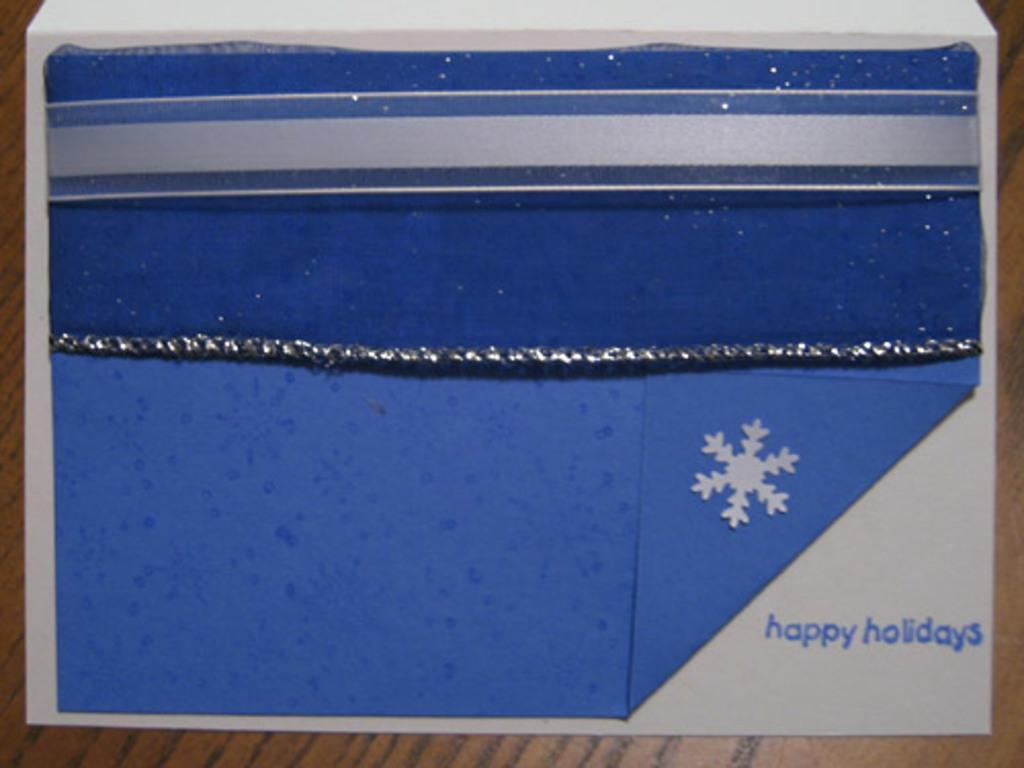<image>
Offer a succinct explanation of the picture presented. Something blue that has a snow flake and the words "Happy holidays" on it. 